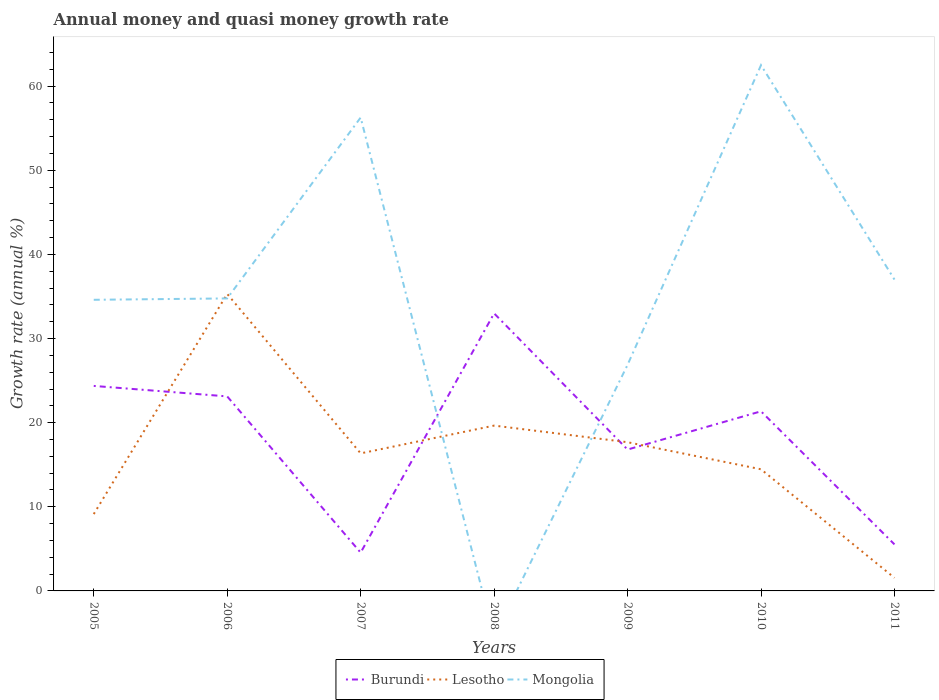Does the line corresponding to Burundi intersect with the line corresponding to Lesotho?
Your response must be concise. Yes. Across all years, what is the maximum growth rate in Lesotho?
Make the answer very short. 1.55. What is the total growth rate in Mongolia in the graph?
Your answer should be very brief. 7.9. What is the difference between the highest and the second highest growth rate in Lesotho?
Offer a terse response. 33.75. Is the growth rate in Burundi strictly greater than the growth rate in Lesotho over the years?
Offer a terse response. No. What is the difference between two consecutive major ticks on the Y-axis?
Offer a very short reply. 10. Does the graph contain any zero values?
Keep it short and to the point. Yes. How many legend labels are there?
Keep it short and to the point. 3. How are the legend labels stacked?
Offer a very short reply. Horizontal. What is the title of the graph?
Your answer should be compact. Annual money and quasi money growth rate. What is the label or title of the Y-axis?
Make the answer very short. Growth rate (annual %). What is the Growth rate (annual %) in Burundi in 2005?
Make the answer very short. 24.37. What is the Growth rate (annual %) in Lesotho in 2005?
Offer a terse response. 9.14. What is the Growth rate (annual %) in Mongolia in 2005?
Keep it short and to the point. 34.61. What is the Growth rate (annual %) in Burundi in 2006?
Your answer should be compact. 23.12. What is the Growth rate (annual %) of Lesotho in 2006?
Ensure brevity in your answer.  35.31. What is the Growth rate (annual %) of Mongolia in 2006?
Provide a short and direct response. 34.77. What is the Growth rate (annual %) in Burundi in 2007?
Make the answer very short. 4.55. What is the Growth rate (annual %) of Lesotho in 2007?
Your answer should be compact. 16.35. What is the Growth rate (annual %) of Mongolia in 2007?
Provide a short and direct response. 56.27. What is the Growth rate (annual %) of Burundi in 2008?
Offer a terse response. 32.99. What is the Growth rate (annual %) of Lesotho in 2008?
Provide a short and direct response. 19.65. What is the Growth rate (annual %) of Mongolia in 2008?
Offer a very short reply. 0. What is the Growth rate (annual %) in Burundi in 2009?
Give a very brief answer. 16.81. What is the Growth rate (annual %) of Lesotho in 2009?
Provide a short and direct response. 17.68. What is the Growth rate (annual %) of Mongolia in 2009?
Your response must be concise. 26.87. What is the Growth rate (annual %) of Burundi in 2010?
Provide a short and direct response. 21.35. What is the Growth rate (annual %) in Lesotho in 2010?
Ensure brevity in your answer.  14.46. What is the Growth rate (annual %) of Mongolia in 2010?
Ensure brevity in your answer.  62.5. What is the Growth rate (annual %) of Burundi in 2011?
Offer a very short reply. 5.53. What is the Growth rate (annual %) in Lesotho in 2011?
Your answer should be very brief. 1.55. What is the Growth rate (annual %) in Mongolia in 2011?
Provide a succinct answer. 37.01. Across all years, what is the maximum Growth rate (annual %) in Burundi?
Your response must be concise. 32.99. Across all years, what is the maximum Growth rate (annual %) of Lesotho?
Your answer should be compact. 35.31. Across all years, what is the maximum Growth rate (annual %) of Mongolia?
Ensure brevity in your answer.  62.5. Across all years, what is the minimum Growth rate (annual %) in Burundi?
Offer a very short reply. 4.55. Across all years, what is the minimum Growth rate (annual %) in Lesotho?
Your answer should be very brief. 1.55. Across all years, what is the minimum Growth rate (annual %) in Mongolia?
Offer a terse response. 0. What is the total Growth rate (annual %) in Burundi in the graph?
Your answer should be compact. 128.72. What is the total Growth rate (annual %) in Lesotho in the graph?
Provide a short and direct response. 114.14. What is the total Growth rate (annual %) in Mongolia in the graph?
Provide a short and direct response. 252.03. What is the difference between the Growth rate (annual %) in Burundi in 2005 and that in 2006?
Provide a succinct answer. 1.25. What is the difference between the Growth rate (annual %) in Lesotho in 2005 and that in 2006?
Ensure brevity in your answer.  -26.17. What is the difference between the Growth rate (annual %) of Mongolia in 2005 and that in 2006?
Give a very brief answer. -0.16. What is the difference between the Growth rate (annual %) in Burundi in 2005 and that in 2007?
Ensure brevity in your answer.  19.82. What is the difference between the Growth rate (annual %) of Lesotho in 2005 and that in 2007?
Provide a succinct answer. -7.21. What is the difference between the Growth rate (annual %) in Mongolia in 2005 and that in 2007?
Keep it short and to the point. -21.66. What is the difference between the Growth rate (annual %) in Burundi in 2005 and that in 2008?
Provide a short and direct response. -8.62. What is the difference between the Growth rate (annual %) of Lesotho in 2005 and that in 2008?
Make the answer very short. -10.52. What is the difference between the Growth rate (annual %) of Burundi in 2005 and that in 2009?
Give a very brief answer. 7.56. What is the difference between the Growth rate (annual %) of Lesotho in 2005 and that in 2009?
Your answer should be compact. -8.54. What is the difference between the Growth rate (annual %) of Mongolia in 2005 and that in 2009?
Keep it short and to the point. 7.73. What is the difference between the Growth rate (annual %) in Burundi in 2005 and that in 2010?
Ensure brevity in your answer.  3.02. What is the difference between the Growth rate (annual %) in Lesotho in 2005 and that in 2010?
Your answer should be compact. -5.32. What is the difference between the Growth rate (annual %) in Mongolia in 2005 and that in 2010?
Offer a very short reply. -27.89. What is the difference between the Growth rate (annual %) in Burundi in 2005 and that in 2011?
Keep it short and to the point. 18.84. What is the difference between the Growth rate (annual %) of Lesotho in 2005 and that in 2011?
Provide a short and direct response. 7.58. What is the difference between the Growth rate (annual %) of Mongolia in 2005 and that in 2011?
Provide a short and direct response. -2.41. What is the difference between the Growth rate (annual %) of Burundi in 2006 and that in 2007?
Offer a terse response. 18.57. What is the difference between the Growth rate (annual %) of Lesotho in 2006 and that in 2007?
Make the answer very short. 18.96. What is the difference between the Growth rate (annual %) of Mongolia in 2006 and that in 2007?
Keep it short and to the point. -21.5. What is the difference between the Growth rate (annual %) in Burundi in 2006 and that in 2008?
Provide a succinct answer. -9.87. What is the difference between the Growth rate (annual %) of Lesotho in 2006 and that in 2008?
Provide a succinct answer. 15.65. What is the difference between the Growth rate (annual %) of Burundi in 2006 and that in 2009?
Keep it short and to the point. 6.32. What is the difference between the Growth rate (annual %) of Lesotho in 2006 and that in 2009?
Offer a very short reply. 17.63. What is the difference between the Growth rate (annual %) of Mongolia in 2006 and that in 2009?
Keep it short and to the point. 7.9. What is the difference between the Growth rate (annual %) in Burundi in 2006 and that in 2010?
Your answer should be very brief. 1.77. What is the difference between the Growth rate (annual %) of Lesotho in 2006 and that in 2010?
Give a very brief answer. 20.85. What is the difference between the Growth rate (annual %) in Mongolia in 2006 and that in 2010?
Your answer should be compact. -27.73. What is the difference between the Growth rate (annual %) of Burundi in 2006 and that in 2011?
Keep it short and to the point. 17.59. What is the difference between the Growth rate (annual %) of Lesotho in 2006 and that in 2011?
Offer a terse response. 33.75. What is the difference between the Growth rate (annual %) in Mongolia in 2006 and that in 2011?
Offer a terse response. -2.24. What is the difference between the Growth rate (annual %) in Burundi in 2007 and that in 2008?
Offer a very short reply. -28.44. What is the difference between the Growth rate (annual %) in Lesotho in 2007 and that in 2008?
Your answer should be compact. -3.3. What is the difference between the Growth rate (annual %) in Burundi in 2007 and that in 2009?
Provide a succinct answer. -12.25. What is the difference between the Growth rate (annual %) in Lesotho in 2007 and that in 2009?
Ensure brevity in your answer.  -1.33. What is the difference between the Growth rate (annual %) in Mongolia in 2007 and that in 2009?
Your answer should be compact. 29.4. What is the difference between the Growth rate (annual %) in Burundi in 2007 and that in 2010?
Make the answer very short. -16.8. What is the difference between the Growth rate (annual %) of Lesotho in 2007 and that in 2010?
Make the answer very short. 1.89. What is the difference between the Growth rate (annual %) of Mongolia in 2007 and that in 2010?
Give a very brief answer. -6.23. What is the difference between the Growth rate (annual %) in Burundi in 2007 and that in 2011?
Your response must be concise. -0.98. What is the difference between the Growth rate (annual %) in Lesotho in 2007 and that in 2011?
Your answer should be compact. 14.8. What is the difference between the Growth rate (annual %) in Mongolia in 2007 and that in 2011?
Ensure brevity in your answer.  19.26. What is the difference between the Growth rate (annual %) of Burundi in 2008 and that in 2009?
Make the answer very short. 16.19. What is the difference between the Growth rate (annual %) of Lesotho in 2008 and that in 2009?
Provide a short and direct response. 1.97. What is the difference between the Growth rate (annual %) of Burundi in 2008 and that in 2010?
Offer a very short reply. 11.64. What is the difference between the Growth rate (annual %) of Lesotho in 2008 and that in 2010?
Ensure brevity in your answer.  5.19. What is the difference between the Growth rate (annual %) in Burundi in 2008 and that in 2011?
Offer a terse response. 27.46. What is the difference between the Growth rate (annual %) in Lesotho in 2008 and that in 2011?
Ensure brevity in your answer.  18.1. What is the difference between the Growth rate (annual %) in Burundi in 2009 and that in 2010?
Offer a very short reply. -4.54. What is the difference between the Growth rate (annual %) in Lesotho in 2009 and that in 2010?
Provide a succinct answer. 3.22. What is the difference between the Growth rate (annual %) in Mongolia in 2009 and that in 2010?
Your answer should be very brief. -35.62. What is the difference between the Growth rate (annual %) of Burundi in 2009 and that in 2011?
Offer a terse response. 11.27. What is the difference between the Growth rate (annual %) in Lesotho in 2009 and that in 2011?
Your answer should be compact. 16.12. What is the difference between the Growth rate (annual %) in Mongolia in 2009 and that in 2011?
Provide a short and direct response. -10.14. What is the difference between the Growth rate (annual %) of Burundi in 2010 and that in 2011?
Your response must be concise. 15.82. What is the difference between the Growth rate (annual %) in Lesotho in 2010 and that in 2011?
Give a very brief answer. 12.9. What is the difference between the Growth rate (annual %) in Mongolia in 2010 and that in 2011?
Keep it short and to the point. 25.48. What is the difference between the Growth rate (annual %) of Burundi in 2005 and the Growth rate (annual %) of Lesotho in 2006?
Your answer should be compact. -10.94. What is the difference between the Growth rate (annual %) of Burundi in 2005 and the Growth rate (annual %) of Mongolia in 2006?
Provide a short and direct response. -10.4. What is the difference between the Growth rate (annual %) of Lesotho in 2005 and the Growth rate (annual %) of Mongolia in 2006?
Provide a succinct answer. -25.63. What is the difference between the Growth rate (annual %) in Burundi in 2005 and the Growth rate (annual %) in Lesotho in 2007?
Give a very brief answer. 8.02. What is the difference between the Growth rate (annual %) of Burundi in 2005 and the Growth rate (annual %) of Mongolia in 2007?
Your response must be concise. -31.9. What is the difference between the Growth rate (annual %) in Lesotho in 2005 and the Growth rate (annual %) in Mongolia in 2007?
Ensure brevity in your answer.  -47.14. What is the difference between the Growth rate (annual %) in Burundi in 2005 and the Growth rate (annual %) in Lesotho in 2008?
Ensure brevity in your answer.  4.72. What is the difference between the Growth rate (annual %) in Burundi in 2005 and the Growth rate (annual %) in Lesotho in 2009?
Provide a succinct answer. 6.69. What is the difference between the Growth rate (annual %) in Burundi in 2005 and the Growth rate (annual %) in Mongolia in 2009?
Your response must be concise. -2.5. What is the difference between the Growth rate (annual %) of Lesotho in 2005 and the Growth rate (annual %) of Mongolia in 2009?
Offer a very short reply. -17.74. What is the difference between the Growth rate (annual %) of Burundi in 2005 and the Growth rate (annual %) of Lesotho in 2010?
Your answer should be compact. 9.91. What is the difference between the Growth rate (annual %) in Burundi in 2005 and the Growth rate (annual %) in Mongolia in 2010?
Keep it short and to the point. -38.13. What is the difference between the Growth rate (annual %) in Lesotho in 2005 and the Growth rate (annual %) in Mongolia in 2010?
Offer a very short reply. -53.36. What is the difference between the Growth rate (annual %) in Burundi in 2005 and the Growth rate (annual %) in Lesotho in 2011?
Give a very brief answer. 22.81. What is the difference between the Growth rate (annual %) of Burundi in 2005 and the Growth rate (annual %) of Mongolia in 2011?
Offer a terse response. -12.65. What is the difference between the Growth rate (annual %) of Lesotho in 2005 and the Growth rate (annual %) of Mongolia in 2011?
Your response must be concise. -27.88. What is the difference between the Growth rate (annual %) of Burundi in 2006 and the Growth rate (annual %) of Lesotho in 2007?
Your response must be concise. 6.77. What is the difference between the Growth rate (annual %) of Burundi in 2006 and the Growth rate (annual %) of Mongolia in 2007?
Your answer should be compact. -33.15. What is the difference between the Growth rate (annual %) of Lesotho in 2006 and the Growth rate (annual %) of Mongolia in 2007?
Ensure brevity in your answer.  -20.97. What is the difference between the Growth rate (annual %) in Burundi in 2006 and the Growth rate (annual %) in Lesotho in 2008?
Keep it short and to the point. 3.47. What is the difference between the Growth rate (annual %) of Burundi in 2006 and the Growth rate (annual %) of Lesotho in 2009?
Ensure brevity in your answer.  5.45. What is the difference between the Growth rate (annual %) in Burundi in 2006 and the Growth rate (annual %) in Mongolia in 2009?
Your answer should be very brief. -3.75. What is the difference between the Growth rate (annual %) of Lesotho in 2006 and the Growth rate (annual %) of Mongolia in 2009?
Your answer should be compact. 8.43. What is the difference between the Growth rate (annual %) of Burundi in 2006 and the Growth rate (annual %) of Lesotho in 2010?
Offer a very short reply. 8.66. What is the difference between the Growth rate (annual %) of Burundi in 2006 and the Growth rate (annual %) of Mongolia in 2010?
Your response must be concise. -39.37. What is the difference between the Growth rate (annual %) of Lesotho in 2006 and the Growth rate (annual %) of Mongolia in 2010?
Ensure brevity in your answer.  -27.19. What is the difference between the Growth rate (annual %) of Burundi in 2006 and the Growth rate (annual %) of Lesotho in 2011?
Your answer should be compact. 21.57. What is the difference between the Growth rate (annual %) in Burundi in 2006 and the Growth rate (annual %) in Mongolia in 2011?
Your response must be concise. -13.89. What is the difference between the Growth rate (annual %) in Lesotho in 2006 and the Growth rate (annual %) in Mongolia in 2011?
Make the answer very short. -1.71. What is the difference between the Growth rate (annual %) in Burundi in 2007 and the Growth rate (annual %) in Lesotho in 2008?
Offer a very short reply. -15.1. What is the difference between the Growth rate (annual %) in Burundi in 2007 and the Growth rate (annual %) in Lesotho in 2009?
Keep it short and to the point. -13.13. What is the difference between the Growth rate (annual %) of Burundi in 2007 and the Growth rate (annual %) of Mongolia in 2009?
Keep it short and to the point. -22.32. What is the difference between the Growth rate (annual %) in Lesotho in 2007 and the Growth rate (annual %) in Mongolia in 2009?
Provide a short and direct response. -10.52. What is the difference between the Growth rate (annual %) of Burundi in 2007 and the Growth rate (annual %) of Lesotho in 2010?
Your answer should be very brief. -9.91. What is the difference between the Growth rate (annual %) in Burundi in 2007 and the Growth rate (annual %) in Mongolia in 2010?
Your answer should be compact. -57.94. What is the difference between the Growth rate (annual %) in Lesotho in 2007 and the Growth rate (annual %) in Mongolia in 2010?
Keep it short and to the point. -46.15. What is the difference between the Growth rate (annual %) of Burundi in 2007 and the Growth rate (annual %) of Lesotho in 2011?
Make the answer very short. 3. What is the difference between the Growth rate (annual %) in Burundi in 2007 and the Growth rate (annual %) in Mongolia in 2011?
Your answer should be very brief. -32.46. What is the difference between the Growth rate (annual %) of Lesotho in 2007 and the Growth rate (annual %) of Mongolia in 2011?
Your response must be concise. -20.66. What is the difference between the Growth rate (annual %) of Burundi in 2008 and the Growth rate (annual %) of Lesotho in 2009?
Ensure brevity in your answer.  15.31. What is the difference between the Growth rate (annual %) in Burundi in 2008 and the Growth rate (annual %) in Mongolia in 2009?
Offer a terse response. 6.12. What is the difference between the Growth rate (annual %) of Lesotho in 2008 and the Growth rate (annual %) of Mongolia in 2009?
Ensure brevity in your answer.  -7.22. What is the difference between the Growth rate (annual %) of Burundi in 2008 and the Growth rate (annual %) of Lesotho in 2010?
Your answer should be very brief. 18.53. What is the difference between the Growth rate (annual %) in Burundi in 2008 and the Growth rate (annual %) in Mongolia in 2010?
Offer a very short reply. -29.51. What is the difference between the Growth rate (annual %) in Lesotho in 2008 and the Growth rate (annual %) in Mongolia in 2010?
Give a very brief answer. -42.85. What is the difference between the Growth rate (annual %) in Burundi in 2008 and the Growth rate (annual %) in Lesotho in 2011?
Ensure brevity in your answer.  31.44. What is the difference between the Growth rate (annual %) in Burundi in 2008 and the Growth rate (annual %) in Mongolia in 2011?
Ensure brevity in your answer.  -4.02. What is the difference between the Growth rate (annual %) of Lesotho in 2008 and the Growth rate (annual %) of Mongolia in 2011?
Give a very brief answer. -17.36. What is the difference between the Growth rate (annual %) of Burundi in 2009 and the Growth rate (annual %) of Lesotho in 2010?
Provide a short and direct response. 2.35. What is the difference between the Growth rate (annual %) in Burundi in 2009 and the Growth rate (annual %) in Mongolia in 2010?
Offer a very short reply. -45.69. What is the difference between the Growth rate (annual %) in Lesotho in 2009 and the Growth rate (annual %) in Mongolia in 2010?
Offer a terse response. -44.82. What is the difference between the Growth rate (annual %) of Burundi in 2009 and the Growth rate (annual %) of Lesotho in 2011?
Ensure brevity in your answer.  15.25. What is the difference between the Growth rate (annual %) in Burundi in 2009 and the Growth rate (annual %) in Mongolia in 2011?
Give a very brief answer. -20.21. What is the difference between the Growth rate (annual %) in Lesotho in 2009 and the Growth rate (annual %) in Mongolia in 2011?
Ensure brevity in your answer.  -19.34. What is the difference between the Growth rate (annual %) in Burundi in 2010 and the Growth rate (annual %) in Lesotho in 2011?
Ensure brevity in your answer.  19.8. What is the difference between the Growth rate (annual %) of Burundi in 2010 and the Growth rate (annual %) of Mongolia in 2011?
Give a very brief answer. -15.66. What is the difference between the Growth rate (annual %) of Lesotho in 2010 and the Growth rate (annual %) of Mongolia in 2011?
Keep it short and to the point. -22.56. What is the average Growth rate (annual %) in Burundi per year?
Provide a succinct answer. 18.39. What is the average Growth rate (annual %) of Lesotho per year?
Provide a succinct answer. 16.31. What is the average Growth rate (annual %) in Mongolia per year?
Provide a succinct answer. 36. In the year 2005, what is the difference between the Growth rate (annual %) in Burundi and Growth rate (annual %) in Lesotho?
Your response must be concise. 15.23. In the year 2005, what is the difference between the Growth rate (annual %) in Burundi and Growth rate (annual %) in Mongolia?
Your answer should be compact. -10.24. In the year 2005, what is the difference between the Growth rate (annual %) in Lesotho and Growth rate (annual %) in Mongolia?
Your answer should be compact. -25.47. In the year 2006, what is the difference between the Growth rate (annual %) of Burundi and Growth rate (annual %) of Lesotho?
Provide a succinct answer. -12.18. In the year 2006, what is the difference between the Growth rate (annual %) in Burundi and Growth rate (annual %) in Mongolia?
Make the answer very short. -11.65. In the year 2006, what is the difference between the Growth rate (annual %) of Lesotho and Growth rate (annual %) of Mongolia?
Your response must be concise. 0.54. In the year 2007, what is the difference between the Growth rate (annual %) in Burundi and Growth rate (annual %) in Lesotho?
Offer a very short reply. -11.8. In the year 2007, what is the difference between the Growth rate (annual %) of Burundi and Growth rate (annual %) of Mongolia?
Provide a succinct answer. -51.72. In the year 2007, what is the difference between the Growth rate (annual %) of Lesotho and Growth rate (annual %) of Mongolia?
Your response must be concise. -39.92. In the year 2008, what is the difference between the Growth rate (annual %) in Burundi and Growth rate (annual %) in Lesotho?
Your answer should be compact. 13.34. In the year 2009, what is the difference between the Growth rate (annual %) in Burundi and Growth rate (annual %) in Lesotho?
Offer a very short reply. -0.87. In the year 2009, what is the difference between the Growth rate (annual %) of Burundi and Growth rate (annual %) of Mongolia?
Keep it short and to the point. -10.07. In the year 2009, what is the difference between the Growth rate (annual %) in Lesotho and Growth rate (annual %) in Mongolia?
Give a very brief answer. -9.2. In the year 2010, what is the difference between the Growth rate (annual %) in Burundi and Growth rate (annual %) in Lesotho?
Ensure brevity in your answer.  6.89. In the year 2010, what is the difference between the Growth rate (annual %) in Burundi and Growth rate (annual %) in Mongolia?
Offer a terse response. -41.15. In the year 2010, what is the difference between the Growth rate (annual %) of Lesotho and Growth rate (annual %) of Mongolia?
Your answer should be very brief. -48.04. In the year 2011, what is the difference between the Growth rate (annual %) of Burundi and Growth rate (annual %) of Lesotho?
Give a very brief answer. 3.98. In the year 2011, what is the difference between the Growth rate (annual %) in Burundi and Growth rate (annual %) in Mongolia?
Offer a terse response. -31.48. In the year 2011, what is the difference between the Growth rate (annual %) in Lesotho and Growth rate (annual %) in Mongolia?
Provide a succinct answer. -35.46. What is the ratio of the Growth rate (annual %) of Burundi in 2005 to that in 2006?
Ensure brevity in your answer.  1.05. What is the ratio of the Growth rate (annual %) of Lesotho in 2005 to that in 2006?
Provide a short and direct response. 0.26. What is the ratio of the Growth rate (annual %) of Mongolia in 2005 to that in 2006?
Keep it short and to the point. 1. What is the ratio of the Growth rate (annual %) of Burundi in 2005 to that in 2007?
Keep it short and to the point. 5.35. What is the ratio of the Growth rate (annual %) in Lesotho in 2005 to that in 2007?
Ensure brevity in your answer.  0.56. What is the ratio of the Growth rate (annual %) of Mongolia in 2005 to that in 2007?
Keep it short and to the point. 0.61. What is the ratio of the Growth rate (annual %) in Burundi in 2005 to that in 2008?
Ensure brevity in your answer.  0.74. What is the ratio of the Growth rate (annual %) in Lesotho in 2005 to that in 2008?
Provide a short and direct response. 0.46. What is the ratio of the Growth rate (annual %) in Burundi in 2005 to that in 2009?
Your answer should be very brief. 1.45. What is the ratio of the Growth rate (annual %) of Lesotho in 2005 to that in 2009?
Keep it short and to the point. 0.52. What is the ratio of the Growth rate (annual %) of Mongolia in 2005 to that in 2009?
Offer a very short reply. 1.29. What is the ratio of the Growth rate (annual %) in Burundi in 2005 to that in 2010?
Provide a succinct answer. 1.14. What is the ratio of the Growth rate (annual %) in Lesotho in 2005 to that in 2010?
Your response must be concise. 0.63. What is the ratio of the Growth rate (annual %) of Mongolia in 2005 to that in 2010?
Provide a short and direct response. 0.55. What is the ratio of the Growth rate (annual %) of Burundi in 2005 to that in 2011?
Keep it short and to the point. 4.41. What is the ratio of the Growth rate (annual %) of Lesotho in 2005 to that in 2011?
Provide a short and direct response. 5.88. What is the ratio of the Growth rate (annual %) of Mongolia in 2005 to that in 2011?
Offer a very short reply. 0.93. What is the ratio of the Growth rate (annual %) of Burundi in 2006 to that in 2007?
Your answer should be very brief. 5.08. What is the ratio of the Growth rate (annual %) of Lesotho in 2006 to that in 2007?
Your response must be concise. 2.16. What is the ratio of the Growth rate (annual %) of Mongolia in 2006 to that in 2007?
Keep it short and to the point. 0.62. What is the ratio of the Growth rate (annual %) of Burundi in 2006 to that in 2008?
Your response must be concise. 0.7. What is the ratio of the Growth rate (annual %) in Lesotho in 2006 to that in 2008?
Offer a terse response. 1.8. What is the ratio of the Growth rate (annual %) of Burundi in 2006 to that in 2009?
Your answer should be very brief. 1.38. What is the ratio of the Growth rate (annual %) in Lesotho in 2006 to that in 2009?
Your response must be concise. 2. What is the ratio of the Growth rate (annual %) in Mongolia in 2006 to that in 2009?
Provide a succinct answer. 1.29. What is the ratio of the Growth rate (annual %) in Burundi in 2006 to that in 2010?
Provide a short and direct response. 1.08. What is the ratio of the Growth rate (annual %) of Lesotho in 2006 to that in 2010?
Offer a terse response. 2.44. What is the ratio of the Growth rate (annual %) in Mongolia in 2006 to that in 2010?
Keep it short and to the point. 0.56. What is the ratio of the Growth rate (annual %) of Burundi in 2006 to that in 2011?
Ensure brevity in your answer.  4.18. What is the ratio of the Growth rate (annual %) in Lesotho in 2006 to that in 2011?
Provide a short and direct response. 22.71. What is the ratio of the Growth rate (annual %) in Mongolia in 2006 to that in 2011?
Ensure brevity in your answer.  0.94. What is the ratio of the Growth rate (annual %) of Burundi in 2007 to that in 2008?
Give a very brief answer. 0.14. What is the ratio of the Growth rate (annual %) of Lesotho in 2007 to that in 2008?
Your answer should be compact. 0.83. What is the ratio of the Growth rate (annual %) of Burundi in 2007 to that in 2009?
Ensure brevity in your answer.  0.27. What is the ratio of the Growth rate (annual %) of Lesotho in 2007 to that in 2009?
Provide a short and direct response. 0.92. What is the ratio of the Growth rate (annual %) in Mongolia in 2007 to that in 2009?
Provide a short and direct response. 2.09. What is the ratio of the Growth rate (annual %) of Burundi in 2007 to that in 2010?
Your response must be concise. 0.21. What is the ratio of the Growth rate (annual %) in Lesotho in 2007 to that in 2010?
Your answer should be compact. 1.13. What is the ratio of the Growth rate (annual %) of Mongolia in 2007 to that in 2010?
Give a very brief answer. 0.9. What is the ratio of the Growth rate (annual %) in Burundi in 2007 to that in 2011?
Provide a short and direct response. 0.82. What is the ratio of the Growth rate (annual %) of Lesotho in 2007 to that in 2011?
Make the answer very short. 10.52. What is the ratio of the Growth rate (annual %) in Mongolia in 2007 to that in 2011?
Keep it short and to the point. 1.52. What is the ratio of the Growth rate (annual %) in Burundi in 2008 to that in 2009?
Offer a very short reply. 1.96. What is the ratio of the Growth rate (annual %) in Lesotho in 2008 to that in 2009?
Make the answer very short. 1.11. What is the ratio of the Growth rate (annual %) in Burundi in 2008 to that in 2010?
Offer a terse response. 1.55. What is the ratio of the Growth rate (annual %) in Lesotho in 2008 to that in 2010?
Provide a short and direct response. 1.36. What is the ratio of the Growth rate (annual %) of Burundi in 2008 to that in 2011?
Make the answer very short. 5.96. What is the ratio of the Growth rate (annual %) in Lesotho in 2008 to that in 2011?
Keep it short and to the point. 12.64. What is the ratio of the Growth rate (annual %) in Burundi in 2009 to that in 2010?
Ensure brevity in your answer.  0.79. What is the ratio of the Growth rate (annual %) in Lesotho in 2009 to that in 2010?
Your answer should be very brief. 1.22. What is the ratio of the Growth rate (annual %) of Mongolia in 2009 to that in 2010?
Ensure brevity in your answer.  0.43. What is the ratio of the Growth rate (annual %) in Burundi in 2009 to that in 2011?
Keep it short and to the point. 3.04. What is the ratio of the Growth rate (annual %) of Lesotho in 2009 to that in 2011?
Your answer should be compact. 11.37. What is the ratio of the Growth rate (annual %) in Mongolia in 2009 to that in 2011?
Ensure brevity in your answer.  0.73. What is the ratio of the Growth rate (annual %) of Burundi in 2010 to that in 2011?
Ensure brevity in your answer.  3.86. What is the ratio of the Growth rate (annual %) of Lesotho in 2010 to that in 2011?
Your answer should be very brief. 9.3. What is the ratio of the Growth rate (annual %) of Mongolia in 2010 to that in 2011?
Offer a very short reply. 1.69. What is the difference between the highest and the second highest Growth rate (annual %) in Burundi?
Offer a very short reply. 8.62. What is the difference between the highest and the second highest Growth rate (annual %) in Lesotho?
Offer a very short reply. 15.65. What is the difference between the highest and the second highest Growth rate (annual %) of Mongolia?
Give a very brief answer. 6.23. What is the difference between the highest and the lowest Growth rate (annual %) in Burundi?
Offer a very short reply. 28.44. What is the difference between the highest and the lowest Growth rate (annual %) in Lesotho?
Offer a very short reply. 33.75. What is the difference between the highest and the lowest Growth rate (annual %) of Mongolia?
Your response must be concise. 62.5. 